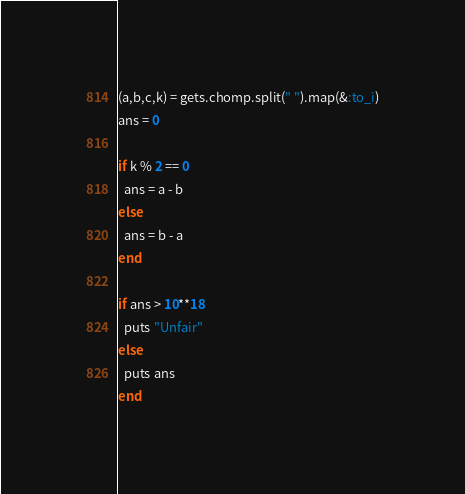Convert code to text. <code><loc_0><loc_0><loc_500><loc_500><_Ruby_>(a,b,c,k) = gets.chomp.split(" ").map(&:to_i)
ans = 0

if k % 2 == 0
  ans = a - b
else
  ans = b - a
end

if ans > 10**18
  puts "Unfair"
else
  puts ans
end
</code> 